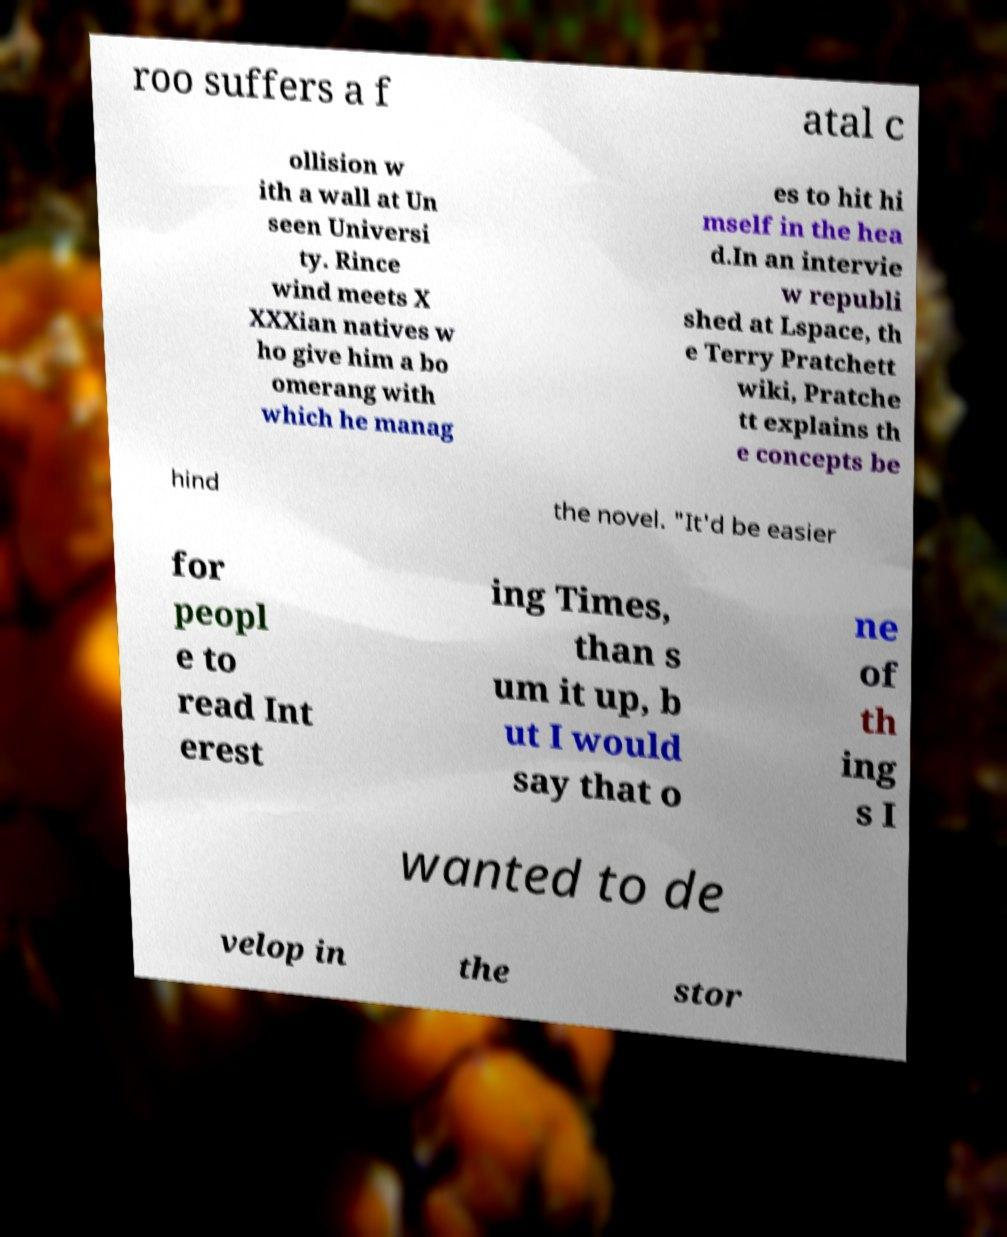Could you extract and type out the text from this image? roo suffers a f atal c ollision w ith a wall at Un seen Universi ty. Rince wind meets X XXXian natives w ho give him a bo omerang with which he manag es to hit hi mself in the hea d.In an intervie w republi shed at Lspace, th e Terry Pratchett wiki, Pratche tt explains th e concepts be hind the novel. "It'd be easier for peopl e to read Int erest ing Times, than s um it up, b ut I would say that o ne of th ing s I wanted to de velop in the stor 